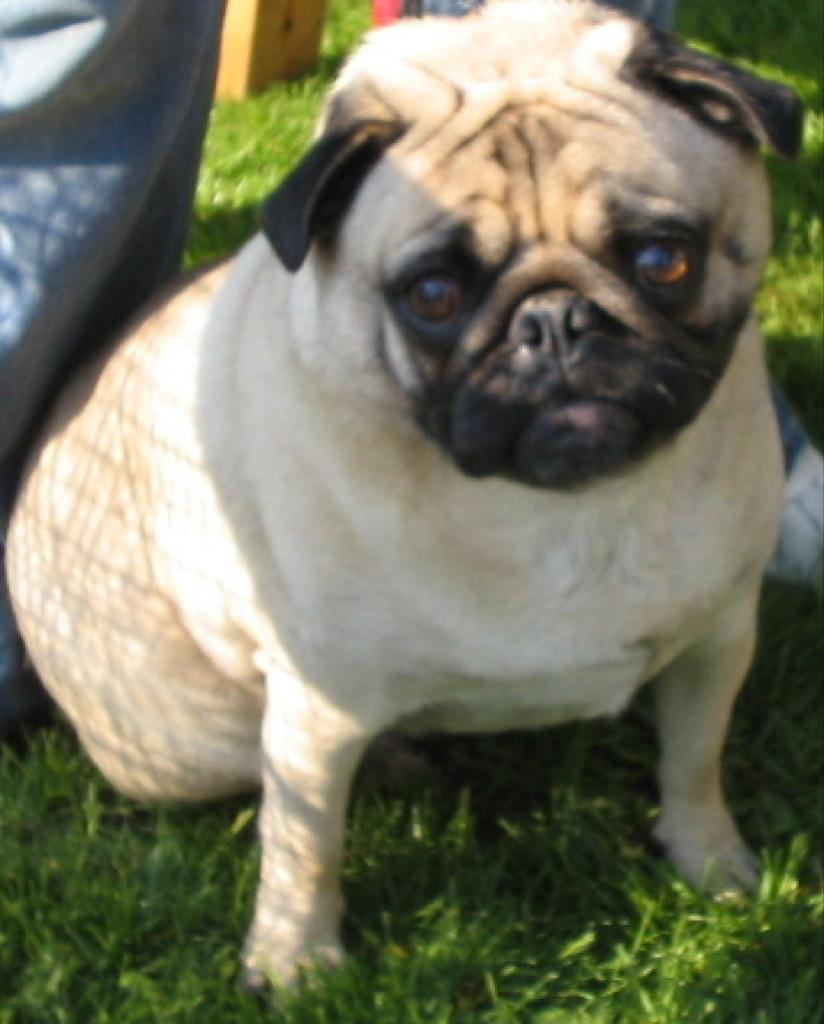What type of animal is present in the image? There is a dog in the image. Where is the dog located? The dog is on a grassland. What type of drink is the dog holding in its hands in the image? There is no drink or hands present in the image, as the dog is an animal and does not have hands. 